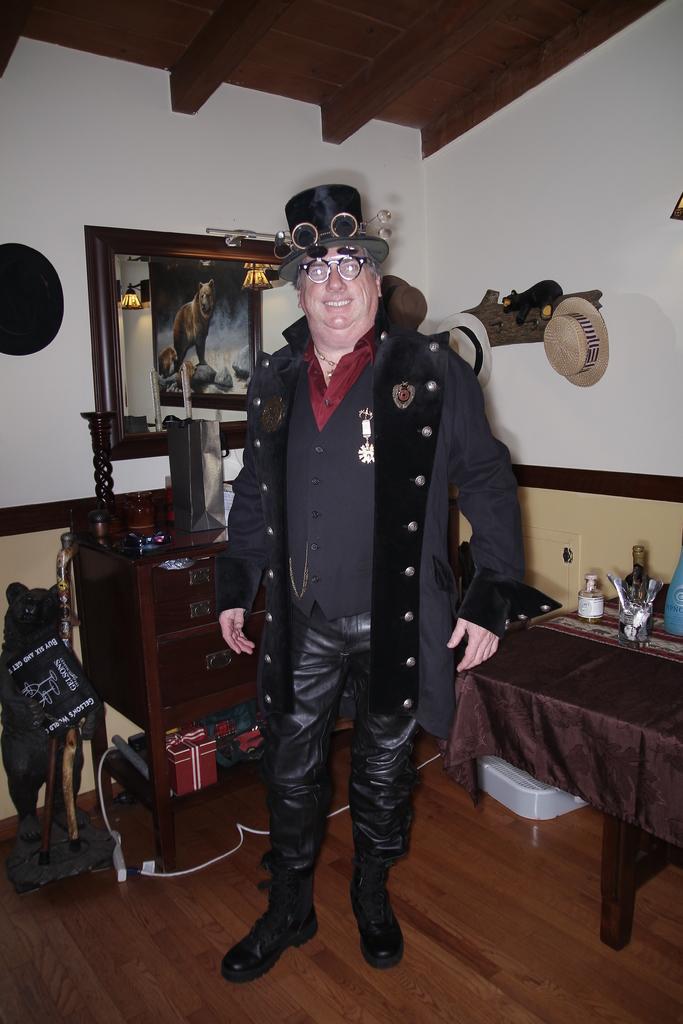In one or two sentences, can you explain what this image depicts? This image is clicked inside a room. There is a man in the middle. He is wearing a black coat. There is a mirror behind him. There are so many things on the right side. There are hats in the middle. 